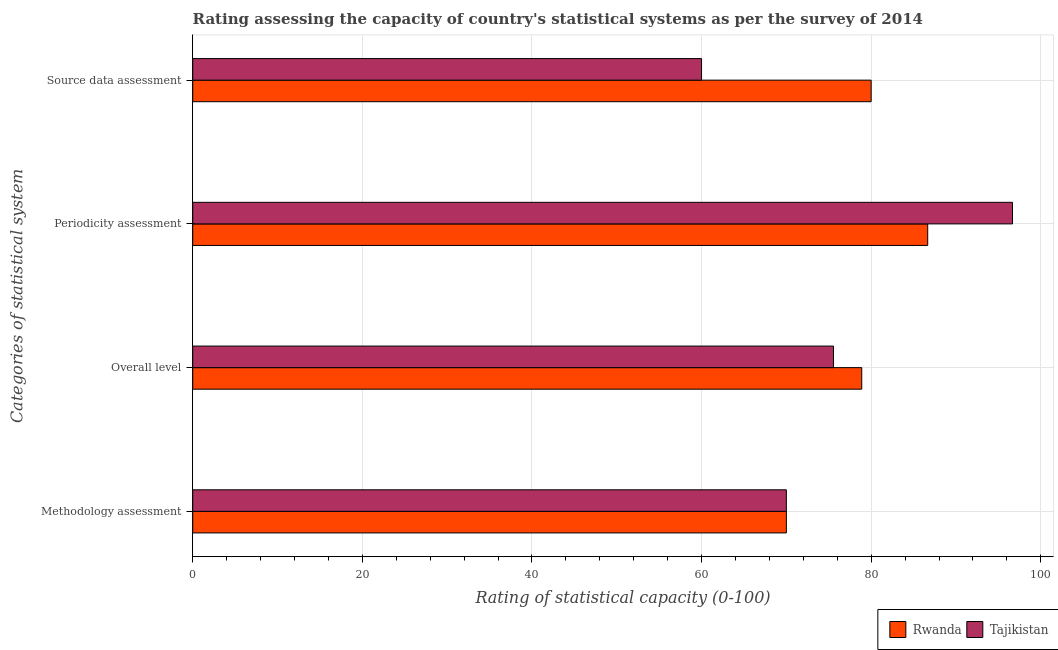How many different coloured bars are there?
Your answer should be compact. 2. How many groups of bars are there?
Offer a terse response. 4. How many bars are there on the 3rd tick from the top?
Give a very brief answer. 2. What is the label of the 3rd group of bars from the top?
Make the answer very short. Overall level. Across all countries, what is the maximum periodicity assessment rating?
Offer a very short reply. 96.67. In which country was the periodicity assessment rating maximum?
Make the answer very short. Tajikistan. In which country was the periodicity assessment rating minimum?
Give a very brief answer. Rwanda. What is the total source data assessment rating in the graph?
Your answer should be very brief. 140. What is the difference between the overall level rating in Tajikistan and that in Rwanda?
Your response must be concise. -3.33. What is the difference between the overall level rating in Tajikistan and the periodicity assessment rating in Rwanda?
Provide a short and direct response. -11.11. What is the average source data assessment rating per country?
Your answer should be compact. 70. What is the difference between the methodology assessment rating and overall level rating in Tajikistan?
Make the answer very short. -5.56. In how many countries, is the periodicity assessment rating greater than 28 ?
Ensure brevity in your answer.  2. What is the ratio of the periodicity assessment rating in Tajikistan to that in Rwanda?
Offer a very short reply. 1.12. What is the difference between the highest and the second highest overall level rating?
Your answer should be compact. 3.33. What does the 1st bar from the top in Methodology assessment represents?
Provide a short and direct response. Tajikistan. What does the 1st bar from the bottom in Overall level represents?
Provide a short and direct response. Rwanda. Is it the case that in every country, the sum of the methodology assessment rating and overall level rating is greater than the periodicity assessment rating?
Your answer should be compact. Yes. How many countries are there in the graph?
Your answer should be compact. 2. What is the difference between two consecutive major ticks on the X-axis?
Make the answer very short. 20. Are the values on the major ticks of X-axis written in scientific E-notation?
Keep it short and to the point. No. Does the graph contain any zero values?
Ensure brevity in your answer.  No. How many legend labels are there?
Your answer should be compact. 2. What is the title of the graph?
Your response must be concise. Rating assessing the capacity of country's statistical systems as per the survey of 2014 . Does "Jamaica" appear as one of the legend labels in the graph?
Your answer should be very brief. No. What is the label or title of the X-axis?
Your response must be concise. Rating of statistical capacity (0-100). What is the label or title of the Y-axis?
Offer a very short reply. Categories of statistical system. What is the Rating of statistical capacity (0-100) in Rwanda in Methodology assessment?
Ensure brevity in your answer.  70. What is the Rating of statistical capacity (0-100) of Rwanda in Overall level?
Ensure brevity in your answer.  78.89. What is the Rating of statistical capacity (0-100) in Tajikistan in Overall level?
Your response must be concise. 75.56. What is the Rating of statistical capacity (0-100) in Rwanda in Periodicity assessment?
Your answer should be compact. 86.67. What is the Rating of statistical capacity (0-100) in Tajikistan in Periodicity assessment?
Offer a terse response. 96.67. Across all Categories of statistical system, what is the maximum Rating of statistical capacity (0-100) in Rwanda?
Offer a terse response. 86.67. Across all Categories of statistical system, what is the maximum Rating of statistical capacity (0-100) in Tajikistan?
Your answer should be very brief. 96.67. Across all Categories of statistical system, what is the minimum Rating of statistical capacity (0-100) of Tajikistan?
Your answer should be very brief. 60. What is the total Rating of statistical capacity (0-100) in Rwanda in the graph?
Give a very brief answer. 315.56. What is the total Rating of statistical capacity (0-100) in Tajikistan in the graph?
Offer a very short reply. 302.22. What is the difference between the Rating of statistical capacity (0-100) of Rwanda in Methodology assessment and that in Overall level?
Provide a succinct answer. -8.89. What is the difference between the Rating of statistical capacity (0-100) in Tajikistan in Methodology assessment and that in Overall level?
Ensure brevity in your answer.  -5.56. What is the difference between the Rating of statistical capacity (0-100) in Rwanda in Methodology assessment and that in Periodicity assessment?
Your answer should be very brief. -16.67. What is the difference between the Rating of statistical capacity (0-100) in Tajikistan in Methodology assessment and that in Periodicity assessment?
Your answer should be compact. -26.67. What is the difference between the Rating of statistical capacity (0-100) in Rwanda in Overall level and that in Periodicity assessment?
Offer a terse response. -7.78. What is the difference between the Rating of statistical capacity (0-100) in Tajikistan in Overall level and that in Periodicity assessment?
Your answer should be compact. -21.11. What is the difference between the Rating of statistical capacity (0-100) in Rwanda in Overall level and that in Source data assessment?
Give a very brief answer. -1.11. What is the difference between the Rating of statistical capacity (0-100) of Tajikistan in Overall level and that in Source data assessment?
Keep it short and to the point. 15.56. What is the difference between the Rating of statistical capacity (0-100) in Rwanda in Periodicity assessment and that in Source data assessment?
Ensure brevity in your answer.  6.67. What is the difference between the Rating of statistical capacity (0-100) of Tajikistan in Periodicity assessment and that in Source data assessment?
Provide a short and direct response. 36.67. What is the difference between the Rating of statistical capacity (0-100) of Rwanda in Methodology assessment and the Rating of statistical capacity (0-100) of Tajikistan in Overall level?
Provide a short and direct response. -5.56. What is the difference between the Rating of statistical capacity (0-100) in Rwanda in Methodology assessment and the Rating of statistical capacity (0-100) in Tajikistan in Periodicity assessment?
Make the answer very short. -26.67. What is the difference between the Rating of statistical capacity (0-100) of Rwanda in Overall level and the Rating of statistical capacity (0-100) of Tajikistan in Periodicity assessment?
Ensure brevity in your answer.  -17.78. What is the difference between the Rating of statistical capacity (0-100) of Rwanda in Overall level and the Rating of statistical capacity (0-100) of Tajikistan in Source data assessment?
Keep it short and to the point. 18.89. What is the difference between the Rating of statistical capacity (0-100) in Rwanda in Periodicity assessment and the Rating of statistical capacity (0-100) in Tajikistan in Source data assessment?
Provide a succinct answer. 26.67. What is the average Rating of statistical capacity (0-100) of Rwanda per Categories of statistical system?
Offer a terse response. 78.89. What is the average Rating of statistical capacity (0-100) in Tajikistan per Categories of statistical system?
Your answer should be compact. 75.56. What is the difference between the Rating of statistical capacity (0-100) in Rwanda and Rating of statistical capacity (0-100) in Tajikistan in Methodology assessment?
Make the answer very short. 0. What is the ratio of the Rating of statistical capacity (0-100) in Rwanda in Methodology assessment to that in Overall level?
Make the answer very short. 0.89. What is the ratio of the Rating of statistical capacity (0-100) in Tajikistan in Methodology assessment to that in Overall level?
Give a very brief answer. 0.93. What is the ratio of the Rating of statistical capacity (0-100) of Rwanda in Methodology assessment to that in Periodicity assessment?
Ensure brevity in your answer.  0.81. What is the ratio of the Rating of statistical capacity (0-100) of Tajikistan in Methodology assessment to that in Periodicity assessment?
Keep it short and to the point. 0.72. What is the ratio of the Rating of statistical capacity (0-100) in Tajikistan in Methodology assessment to that in Source data assessment?
Offer a very short reply. 1.17. What is the ratio of the Rating of statistical capacity (0-100) of Rwanda in Overall level to that in Periodicity assessment?
Keep it short and to the point. 0.91. What is the ratio of the Rating of statistical capacity (0-100) in Tajikistan in Overall level to that in Periodicity assessment?
Your answer should be very brief. 0.78. What is the ratio of the Rating of statistical capacity (0-100) of Rwanda in Overall level to that in Source data assessment?
Keep it short and to the point. 0.99. What is the ratio of the Rating of statistical capacity (0-100) of Tajikistan in Overall level to that in Source data assessment?
Your answer should be very brief. 1.26. What is the ratio of the Rating of statistical capacity (0-100) of Tajikistan in Periodicity assessment to that in Source data assessment?
Ensure brevity in your answer.  1.61. What is the difference between the highest and the second highest Rating of statistical capacity (0-100) of Tajikistan?
Provide a succinct answer. 21.11. What is the difference between the highest and the lowest Rating of statistical capacity (0-100) in Rwanda?
Keep it short and to the point. 16.67. What is the difference between the highest and the lowest Rating of statistical capacity (0-100) in Tajikistan?
Give a very brief answer. 36.67. 